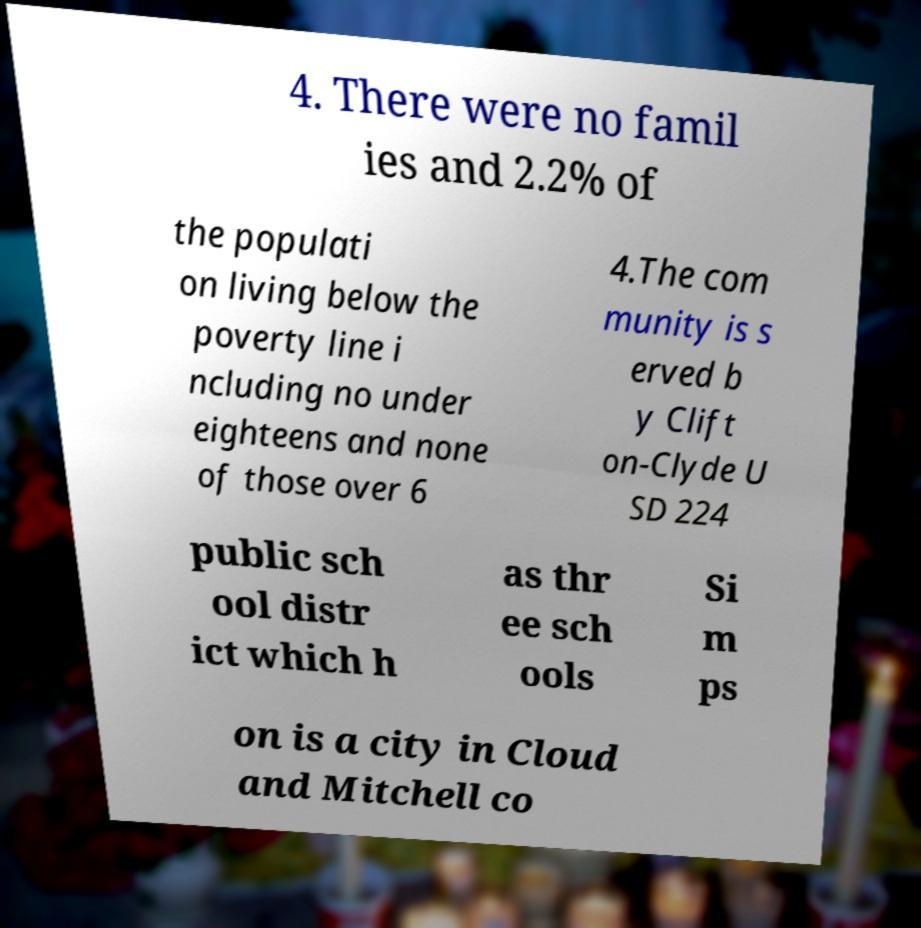What messages or text are displayed in this image? I need them in a readable, typed format. 4. There were no famil ies and 2.2% of the populati on living below the poverty line i ncluding no under eighteens and none of those over 6 4.The com munity is s erved b y Clift on-Clyde U SD 224 public sch ool distr ict which h as thr ee sch ools Si m ps on is a city in Cloud and Mitchell co 